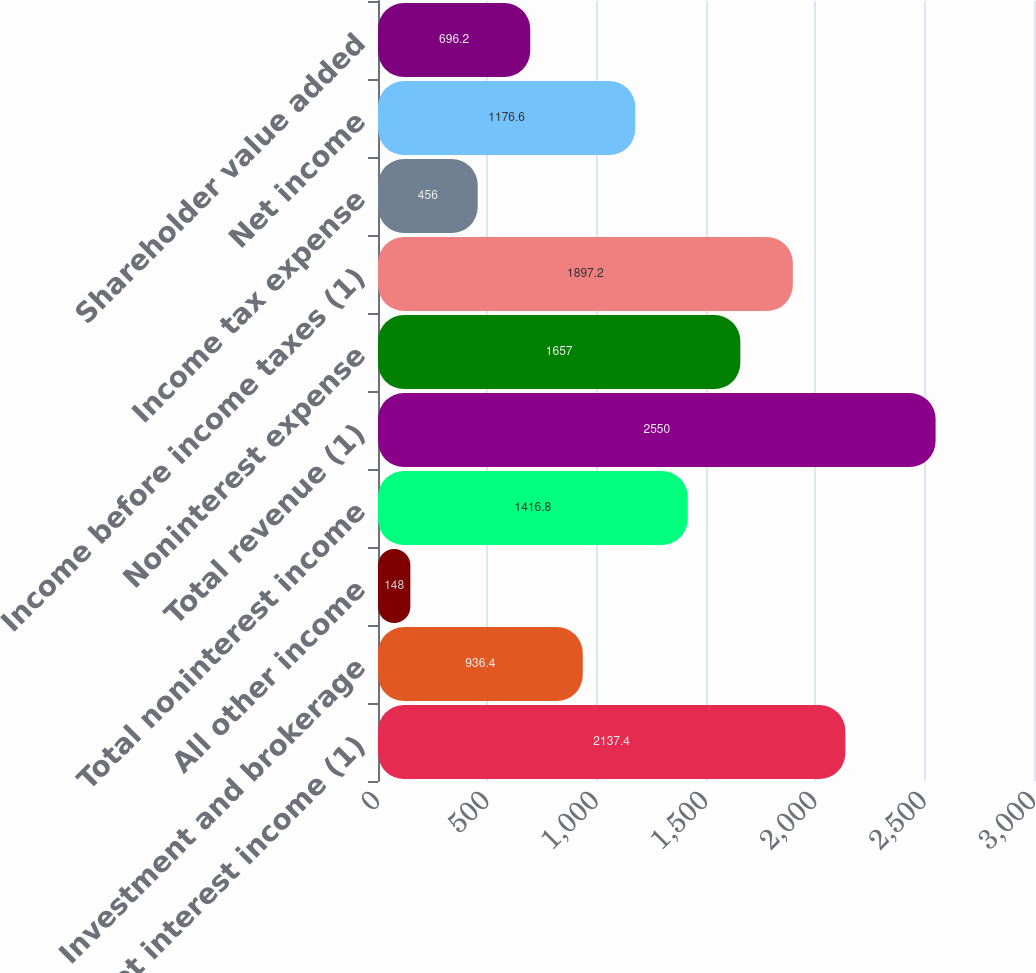Convert chart. <chart><loc_0><loc_0><loc_500><loc_500><bar_chart><fcel>Net interest income (1)<fcel>Investment and brokerage<fcel>All other income<fcel>Total noninterest income<fcel>Total revenue (1)<fcel>Noninterest expense<fcel>Income before income taxes (1)<fcel>Income tax expense<fcel>Net income<fcel>Shareholder value added<nl><fcel>2137.4<fcel>936.4<fcel>148<fcel>1416.8<fcel>2550<fcel>1657<fcel>1897.2<fcel>456<fcel>1176.6<fcel>696.2<nl></chart> 